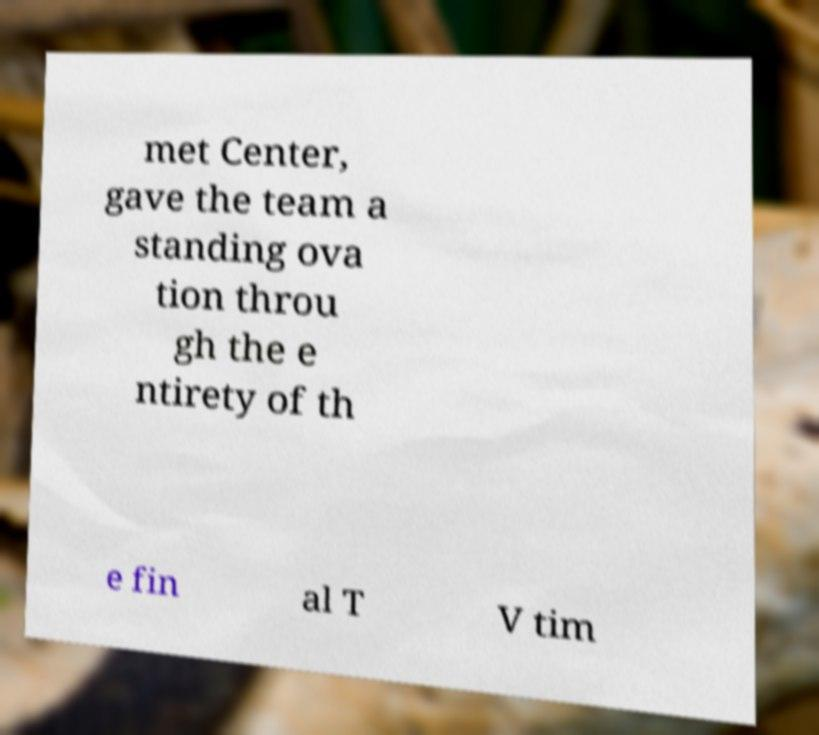For documentation purposes, I need the text within this image transcribed. Could you provide that? met Center, gave the team a standing ova tion throu gh the e ntirety of th e fin al T V tim 